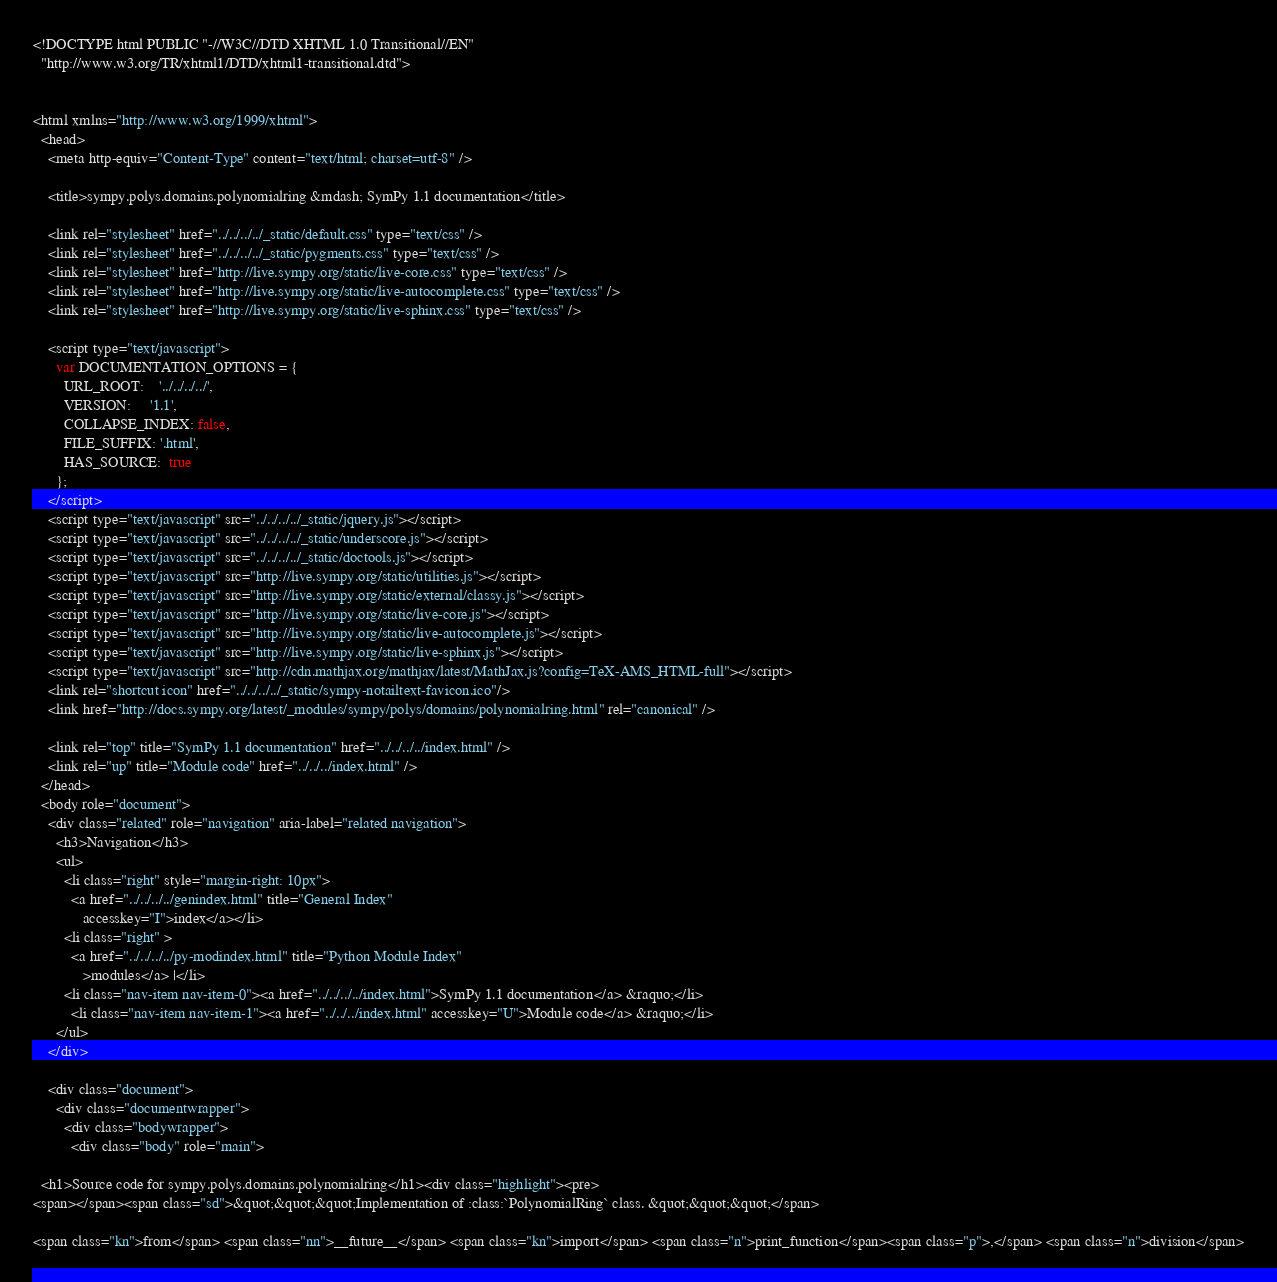<code> <loc_0><loc_0><loc_500><loc_500><_HTML_><!DOCTYPE html PUBLIC "-//W3C//DTD XHTML 1.0 Transitional//EN"
  "http://www.w3.org/TR/xhtml1/DTD/xhtml1-transitional.dtd">


<html xmlns="http://www.w3.org/1999/xhtml">
  <head>
    <meta http-equiv="Content-Type" content="text/html; charset=utf-8" />
    
    <title>sympy.polys.domains.polynomialring &mdash; SymPy 1.1 documentation</title>
    
    <link rel="stylesheet" href="../../../../_static/default.css" type="text/css" />
    <link rel="stylesheet" href="../../../../_static/pygments.css" type="text/css" />
    <link rel="stylesheet" href="http://live.sympy.org/static/live-core.css" type="text/css" />
    <link rel="stylesheet" href="http://live.sympy.org/static/live-autocomplete.css" type="text/css" />
    <link rel="stylesheet" href="http://live.sympy.org/static/live-sphinx.css" type="text/css" />
    
    <script type="text/javascript">
      var DOCUMENTATION_OPTIONS = {
        URL_ROOT:    '../../../../',
        VERSION:     '1.1',
        COLLAPSE_INDEX: false,
        FILE_SUFFIX: '.html',
        HAS_SOURCE:  true
      };
    </script>
    <script type="text/javascript" src="../../../../_static/jquery.js"></script>
    <script type="text/javascript" src="../../../../_static/underscore.js"></script>
    <script type="text/javascript" src="../../../../_static/doctools.js"></script>
    <script type="text/javascript" src="http://live.sympy.org/static/utilities.js"></script>
    <script type="text/javascript" src="http://live.sympy.org/static/external/classy.js"></script>
    <script type="text/javascript" src="http://live.sympy.org/static/live-core.js"></script>
    <script type="text/javascript" src="http://live.sympy.org/static/live-autocomplete.js"></script>
    <script type="text/javascript" src="http://live.sympy.org/static/live-sphinx.js"></script>
    <script type="text/javascript" src="http://cdn.mathjax.org/mathjax/latest/MathJax.js?config=TeX-AMS_HTML-full"></script>
    <link rel="shortcut icon" href="../../../../_static/sympy-notailtext-favicon.ico"/>
    <link href="http://docs.sympy.org/latest/_modules/sympy/polys/domains/polynomialring.html" rel="canonical" />
    
    <link rel="top" title="SymPy 1.1 documentation" href="../../../../index.html" />
    <link rel="up" title="Module code" href="../../../index.html" /> 
  </head>
  <body role="document">
    <div class="related" role="navigation" aria-label="related navigation">
      <h3>Navigation</h3>
      <ul>
        <li class="right" style="margin-right: 10px">
          <a href="../../../../genindex.html" title="General Index"
             accesskey="I">index</a></li>
        <li class="right" >
          <a href="../../../../py-modindex.html" title="Python Module Index"
             >modules</a> |</li>
        <li class="nav-item nav-item-0"><a href="../../../../index.html">SymPy 1.1 documentation</a> &raquo;</li>
          <li class="nav-item nav-item-1"><a href="../../../index.html" accesskey="U">Module code</a> &raquo;</li> 
      </ul>
    </div>  

    <div class="document">
      <div class="documentwrapper">
        <div class="bodywrapper">
          <div class="body" role="main">
            
  <h1>Source code for sympy.polys.domains.polynomialring</h1><div class="highlight"><pre>
<span></span><span class="sd">&quot;&quot;&quot;Implementation of :class:`PolynomialRing` class. &quot;&quot;&quot;</span>

<span class="kn">from</span> <span class="nn">__future__</span> <span class="kn">import</span> <span class="n">print_function</span><span class="p">,</span> <span class="n">division</span>
</code> 